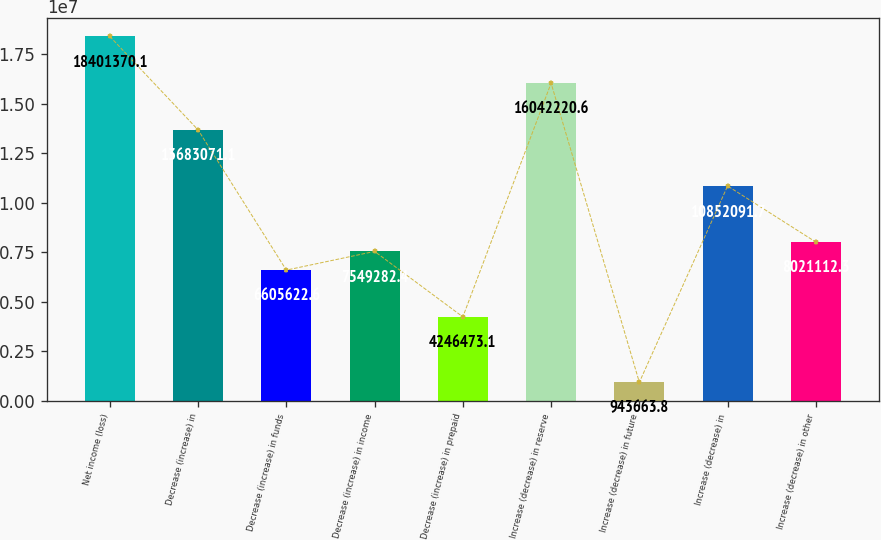<chart> <loc_0><loc_0><loc_500><loc_500><bar_chart><fcel>Net income (loss)<fcel>Decrease (increase) in<fcel>Decrease (increase) in funds<fcel>Decrease (increase) in income<fcel>Decrease (increase) in prepaid<fcel>Increase (decrease) in reserve<fcel>Increase (decrease) in future<fcel>Increase (decrease) in<fcel>Increase (decrease) in other<nl><fcel>1.84014e+07<fcel>1.36831e+07<fcel>6.60562e+06<fcel>7.54928e+06<fcel>4.24647e+06<fcel>1.60422e+07<fcel>943664<fcel>1.08521e+07<fcel>8.02111e+06<nl></chart> 